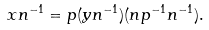Convert formula to latex. <formula><loc_0><loc_0><loc_500><loc_500>x n ^ { - 1 } = p ( y n ^ { - 1 } ) ( n p ^ { - 1 } n ^ { - 1 } ) .</formula> 